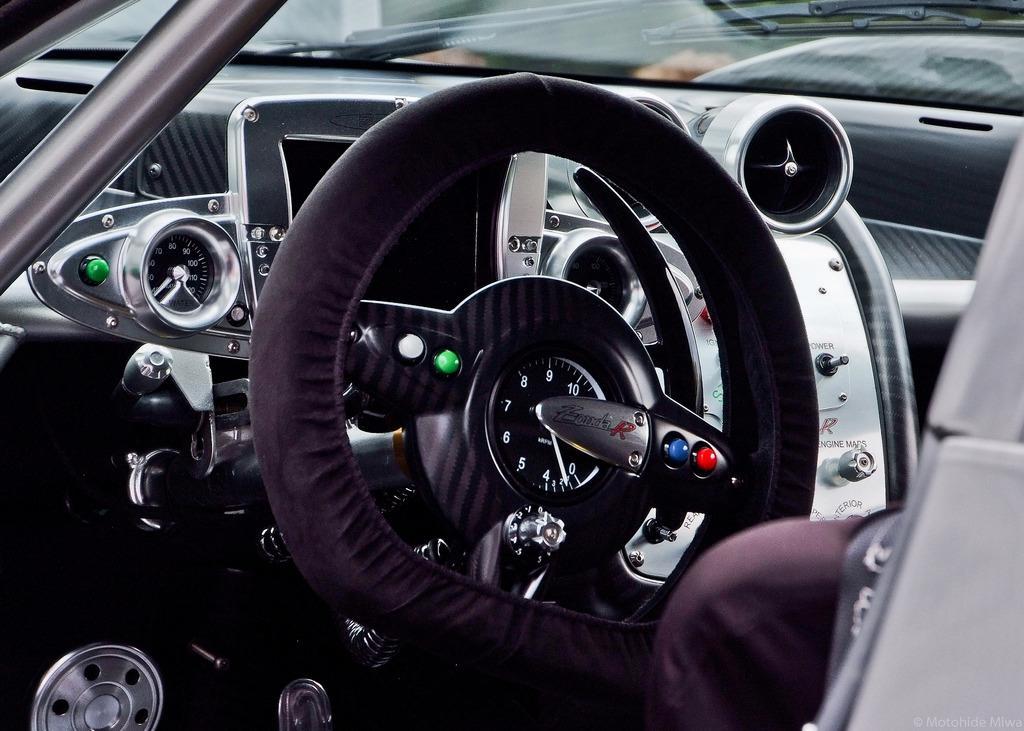Can you describe this image briefly? In this image we can see a car's steering, speedometer and windshield. 